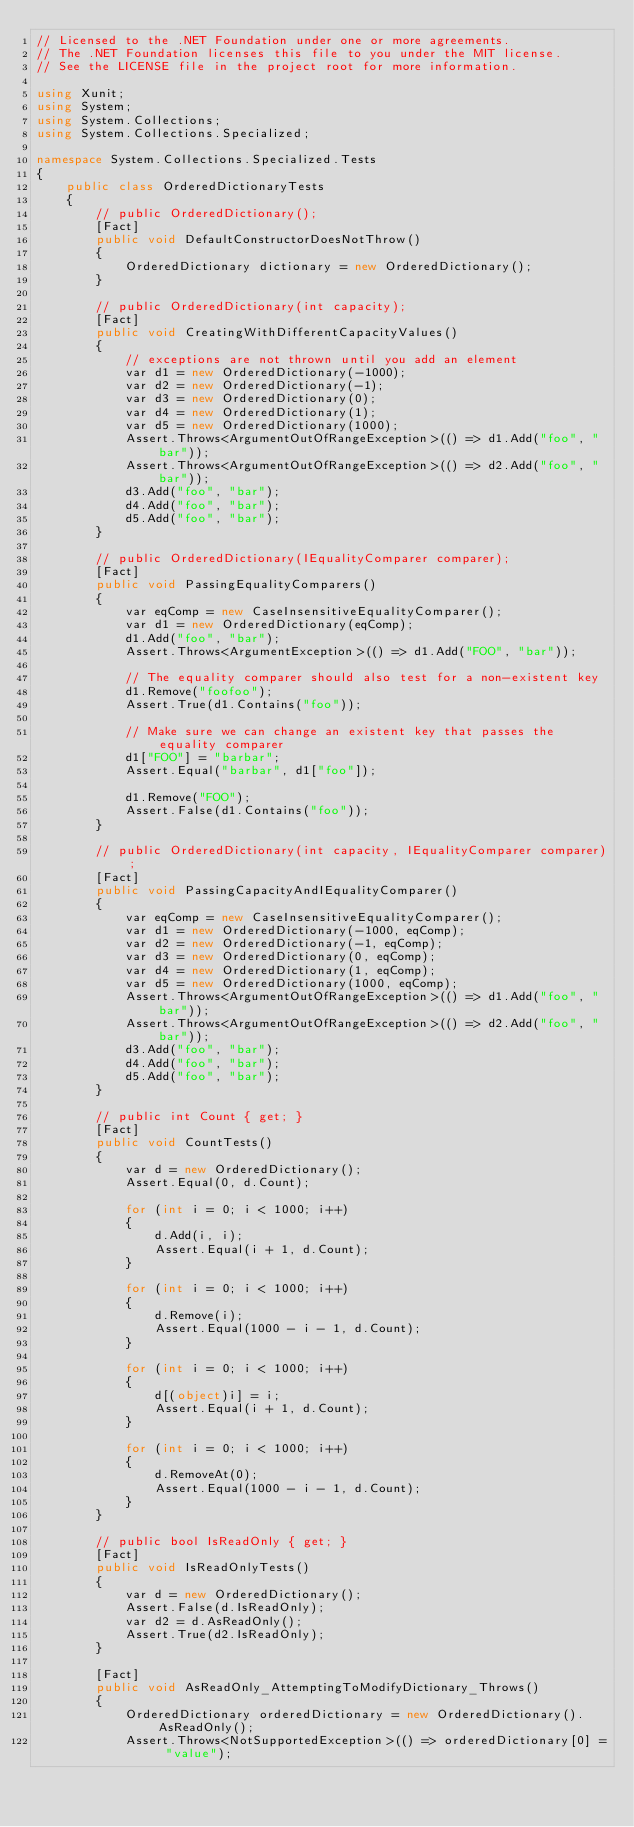<code> <loc_0><loc_0><loc_500><loc_500><_C#_>// Licensed to the .NET Foundation under one or more agreements.
// The .NET Foundation licenses this file to you under the MIT license.
// See the LICENSE file in the project root for more information.

using Xunit;
using System;
using System.Collections;
using System.Collections.Specialized;

namespace System.Collections.Specialized.Tests
{
    public class OrderedDictionaryTests
    {
        // public OrderedDictionary();
        [Fact]
        public void DefaultConstructorDoesNotThrow()
        {
            OrderedDictionary dictionary = new OrderedDictionary();
        }

        // public OrderedDictionary(int capacity);
        [Fact]
        public void CreatingWithDifferentCapacityValues()
        {
            // exceptions are not thrown until you add an element
            var d1 = new OrderedDictionary(-1000);
            var d2 = new OrderedDictionary(-1);
            var d3 = new OrderedDictionary(0);
            var d4 = new OrderedDictionary(1);
            var d5 = new OrderedDictionary(1000);
            Assert.Throws<ArgumentOutOfRangeException>(() => d1.Add("foo", "bar"));
            Assert.Throws<ArgumentOutOfRangeException>(() => d2.Add("foo", "bar"));
            d3.Add("foo", "bar");
            d4.Add("foo", "bar");
            d5.Add("foo", "bar");
        }

        // public OrderedDictionary(IEqualityComparer comparer);
        [Fact]
        public void PassingEqualityComparers()
        {
            var eqComp = new CaseInsensitiveEqualityComparer();
            var d1 = new OrderedDictionary(eqComp);
            d1.Add("foo", "bar");
            Assert.Throws<ArgumentException>(() => d1.Add("FOO", "bar"));

            // The equality comparer should also test for a non-existent key 
            d1.Remove("foofoo");
            Assert.True(d1.Contains("foo"));

            // Make sure we can change an existent key that passes the equality comparer
            d1["FOO"] = "barbar";
            Assert.Equal("barbar", d1["foo"]);

            d1.Remove("FOO");
            Assert.False(d1.Contains("foo"));
        }

        // public OrderedDictionary(int capacity, IEqualityComparer comparer);
        [Fact]
        public void PassingCapacityAndIEqualityComparer()
        {
            var eqComp = new CaseInsensitiveEqualityComparer();
            var d1 = new OrderedDictionary(-1000, eqComp);
            var d2 = new OrderedDictionary(-1, eqComp);
            var d3 = new OrderedDictionary(0, eqComp);
            var d4 = new OrderedDictionary(1, eqComp);
            var d5 = new OrderedDictionary(1000, eqComp);
            Assert.Throws<ArgumentOutOfRangeException>(() => d1.Add("foo", "bar"));
            Assert.Throws<ArgumentOutOfRangeException>(() => d2.Add("foo", "bar"));
            d3.Add("foo", "bar");
            d4.Add("foo", "bar");
            d5.Add("foo", "bar");
        }

        // public int Count { get; }
        [Fact]
        public void CountTests()
        {
            var d = new OrderedDictionary();
            Assert.Equal(0, d.Count);

            for (int i = 0; i < 1000; i++)
            {
                d.Add(i, i);
                Assert.Equal(i + 1, d.Count);
            }

            for (int i = 0; i < 1000; i++)
            {
                d.Remove(i);
                Assert.Equal(1000 - i - 1, d.Count);
            }

            for (int i = 0; i < 1000; i++)
            {
                d[(object)i] = i;
                Assert.Equal(i + 1, d.Count);
            }

            for (int i = 0; i < 1000; i++)
            {
                d.RemoveAt(0);
                Assert.Equal(1000 - i - 1, d.Count);
            }
        }

        // public bool IsReadOnly { get; }
        [Fact]
        public void IsReadOnlyTests()
        {
            var d = new OrderedDictionary();
            Assert.False(d.IsReadOnly);
            var d2 = d.AsReadOnly();
            Assert.True(d2.IsReadOnly);
        }

        [Fact]
        public void AsReadOnly_AttemptingToModifyDictionary_Throws()
        {
            OrderedDictionary orderedDictionary = new OrderedDictionary().AsReadOnly();
            Assert.Throws<NotSupportedException>(() => orderedDictionary[0] = "value");</code> 